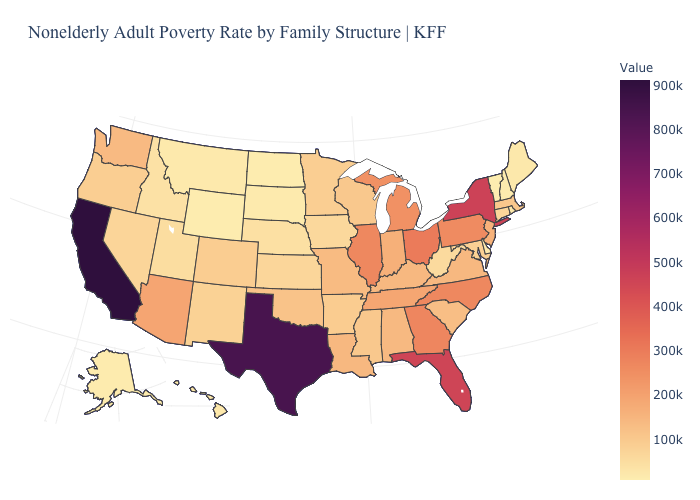Among the states that border New York , which have the highest value?
Give a very brief answer. Pennsylvania. Is the legend a continuous bar?
Write a very short answer. Yes. Does Mississippi have the highest value in the South?
Keep it brief. No. Does Illinois have a higher value than Montana?
Give a very brief answer. Yes. Does Vermont have the lowest value in the USA?
Short answer required. Yes. Which states have the lowest value in the USA?
Answer briefly. Vermont. Which states have the lowest value in the USA?
Answer briefly. Vermont. Does Texas have a lower value than Kentucky?
Be succinct. No. Does the map have missing data?
Answer briefly. No. 